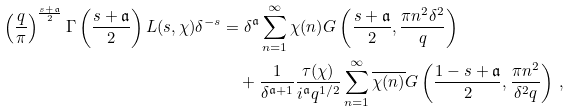<formula> <loc_0><loc_0><loc_500><loc_500>\left ( \frac { q } { \pi } \right ) ^ { \frac { s + \mathfrak { a } } { 2 } } \Gamma \left ( \frac { s + \mathfrak { a } } { 2 } \right ) L ( s , \chi ) \delta ^ { - s } & = \delta ^ { \mathfrak { a } } \sum _ { n = 1 } ^ { \infty } \chi ( n ) G \left ( \frac { s + \mathfrak { a } } { 2 } , \frac { \pi n ^ { 2 } \delta ^ { 2 } } { q } \right ) \\ & \quad + \frac { 1 } { \delta ^ { \mathfrak { a } + 1 } } \frac { \tau ( \chi ) } { i ^ { \mathfrak { a } } q ^ { 1 / 2 } } \sum _ { n = 1 } ^ { \infty } \overline { \chi ( n ) } G \left ( \frac { 1 - s + \mathfrak { a } } { 2 } , \frac { \pi n ^ { 2 } } { \delta ^ { 2 } q } \right ) \, ,</formula> 